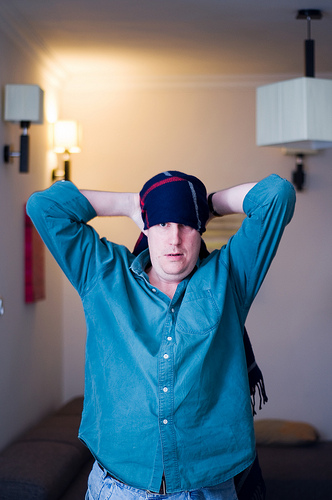<image>
Is there a scarf on the couch? No. The scarf is not positioned on the couch. They may be near each other, but the scarf is not supported by or resting on top of the couch. Where is the man in relation to the wall? Is it in front of the wall? Yes. The man is positioned in front of the wall, appearing closer to the camera viewpoint. 